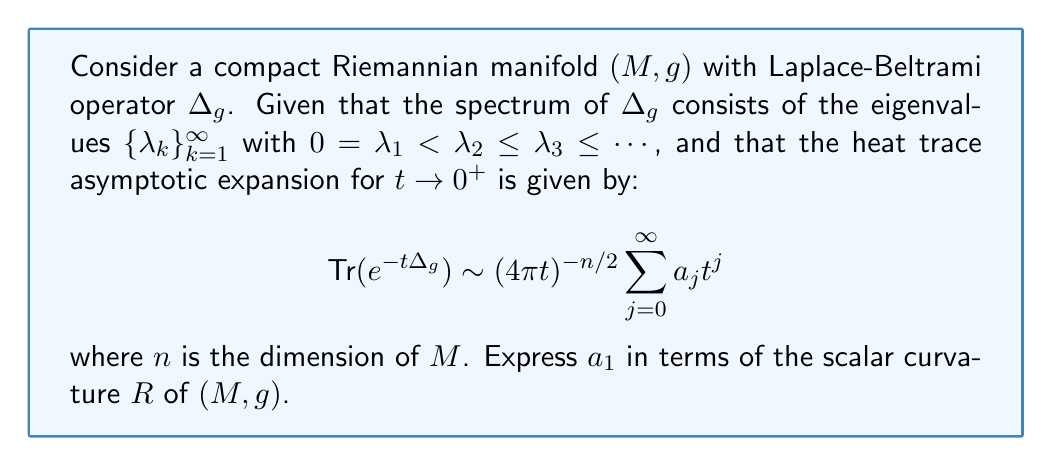Give your solution to this math problem. To solve this problem, we'll follow these steps:

1) Recall that the heat trace $\text{Tr}(e^{-t\Delta_g})$ is related to the spectrum of the Laplace-Beltrami operator by:

   $$\text{Tr}(e^{-t\Delta_g}) = \sum_{k=1}^{\infty} e^{-t\lambda_k}$$

2) The asymptotic expansion of the heat trace for small $t$ contains geometric information about the manifold. The coefficients $a_j$ are called the heat invariants.

3) For a compact Riemannian manifold of dimension $n$, the first few heat invariants are known:

   $a_0 = \text{Vol}(M)$
   $a_1 = \frac{1}{6}\int_M R \, dV$

   where $R$ is the scalar curvature and $dV$ is the volume form.

4) The question asks specifically about $a_1$. From the above, we can see that:

   $$a_1 = \frac{1}{6}\int_M R \, dV$$

5) To express this in terms of the average scalar curvature, we can divide by the volume of $M$:

   $$\frac{a_1}{\text{Vol}(M)} = \frac{1}{6}\frac{\int_M R \, dV}{\text{Vol}(M)} = \frac{1}{6}\overline{R}$$

   where $\overline{R}$ is the average scalar curvature.

6) Rearranging this equation, we get:

   $$a_1 = \frac{1}{6}\overline{R} \cdot \text{Vol}(M)$$

This expression relates $a_1$ to the scalar curvature $R$ of the manifold $(M,g)$.
Answer: $a_1 = \frac{1}{6}\overline{R} \cdot \text{Vol}(M)$ 